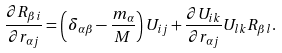<formula> <loc_0><loc_0><loc_500><loc_500>\frac { \partial R _ { \beta i } } { \partial r _ { \alpha j } } = \left ( \delta _ { \alpha \beta } - \frac { m _ { \alpha } } { M } \right ) U _ { i j } + \frac { \partial U _ { i k } } { \partial r _ { \alpha j } } U _ { l k } R _ { \beta l } .</formula> 